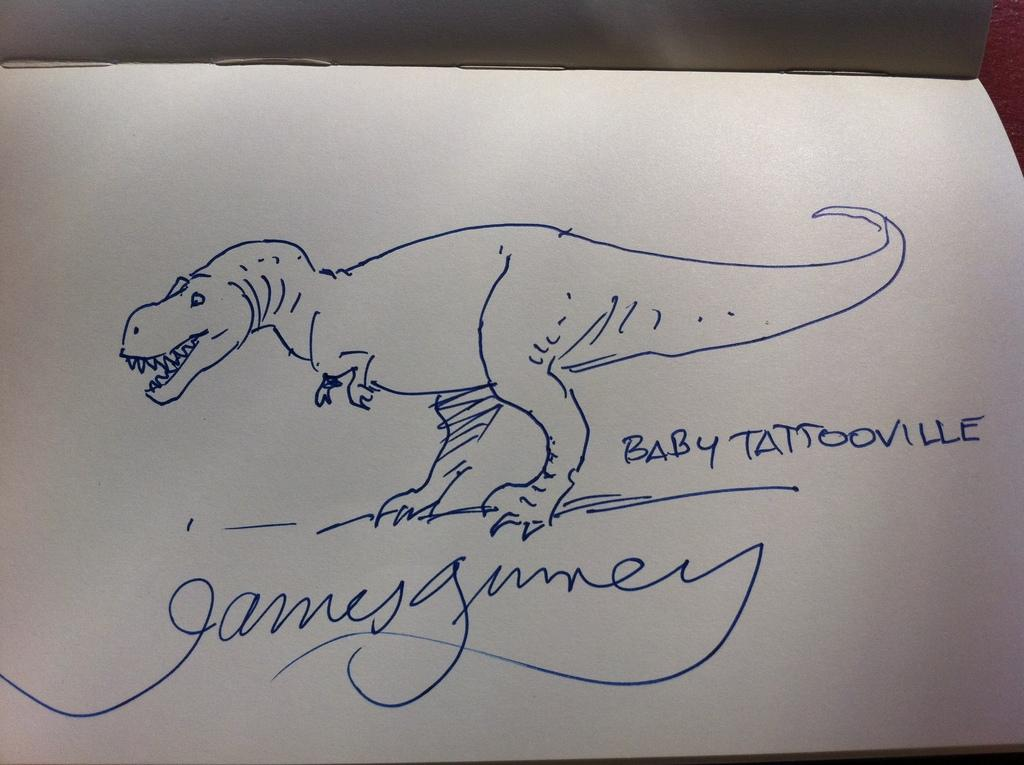What is depicted in the drawing in the image? There is a drawing of a dinosaur in the image. What else can be seen on the white paper in the image? There is text on a white paper in the image. What type of object is the image likely to be a part of? The image appears to be a book. How does the woman in the image express her fear of the dinosaur? There is no woman present in the image, nor is there any indication of fear or a dinosaur expressing fear. 